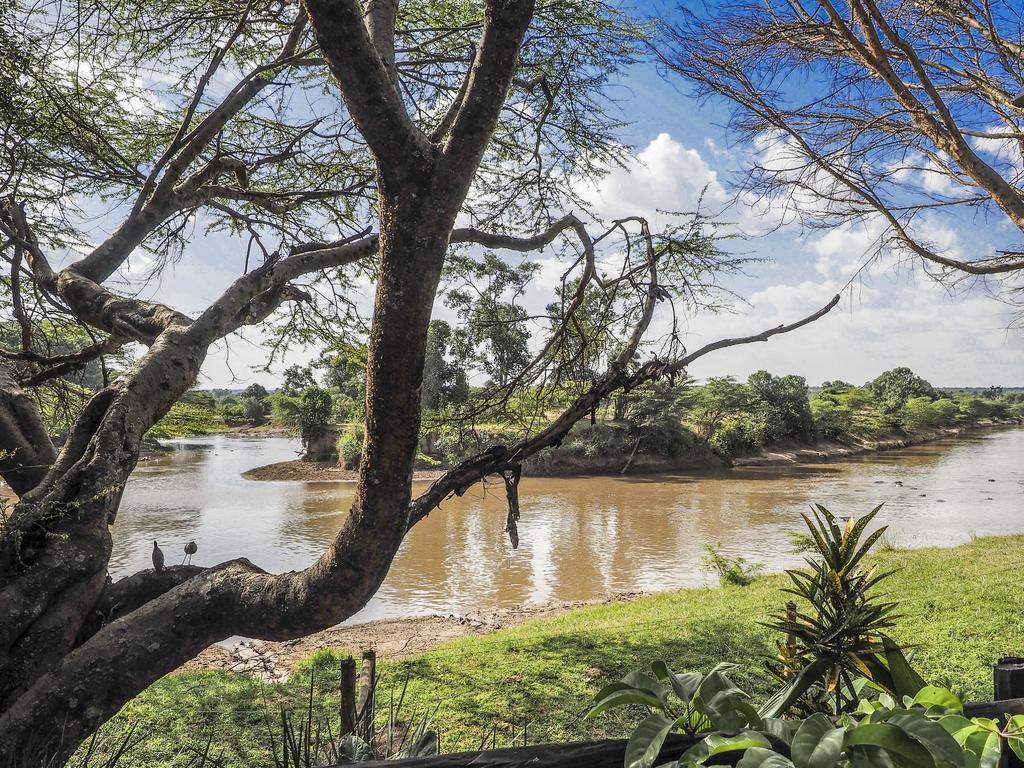Could you give a brief overview of what you see in this image? In the picture we can see a part of a tree under it we can see a grass surface with some plants on it and near the surface we can see a lake with brown color water and behind it, we can see a surface with full of plants on it and in the background we can see the sky with clouds. 